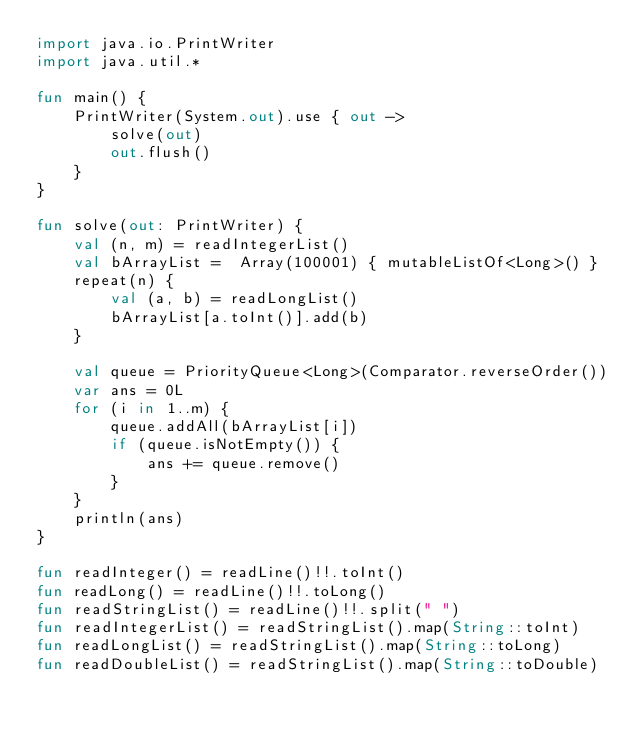Convert code to text. <code><loc_0><loc_0><loc_500><loc_500><_Kotlin_>import java.io.PrintWriter
import java.util.*

fun main() {
    PrintWriter(System.out).use { out ->
        solve(out)
        out.flush()
    }
}

fun solve(out: PrintWriter) {
    val (n, m) = readIntegerList()
    val bArrayList =  Array(100001) { mutableListOf<Long>() }
    repeat(n) {
        val (a, b) = readLongList()
        bArrayList[a.toInt()].add(b)
    }

    val queue = PriorityQueue<Long>(Comparator.reverseOrder())
    var ans = 0L
    for (i in 1..m) {
        queue.addAll(bArrayList[i])
        if (queue.isNotEmpty()) {
            ans += queue.remove()
        }
    }
    println(ans)
}

fun readInteger() = readLine()!!.toInt()
fun readLong() = readLine()!!.toLong()
fun readStringList() = readLine()!!.split(" ")
fun readIntegerList() = readStringList().map(String::toInt)
fun readLongList() = readStringList().map(String::toLong)
fun readDoubleList() = readStringList().map(String::toDouble)
</code> 